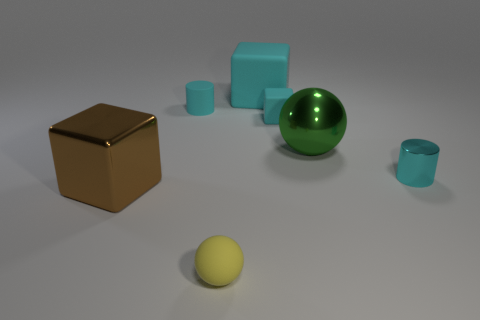What number of things are green objects that are left of the tiny metal thing or tiny objects that are in front of the small cyan cube?
Make the answer very short. 3. Is the number of large rubber blocks that are left of the big cyan rubber thing greater than the number of big blue blocks?
Your answer should be very brief. No. How many cyan rubber cubes have the same size as the green metallic ball?
Give a very brief answer. 1. Do the object in front of the brown cube and the sphere that is to the right of the tiny yellow sphere have the same size?
Provide a succinct answer. No. There is a ball in front of the large ball; how big is it?
Provide a short and direct response. Small. What size is the cyan cylinder to the left of the cyan cylinder on the right side of the large metal sphere?
Ensure brevity in your answer.  Small. There is a cyan cube that is the same size as the green sphere; what is it made of?
Ensure brevity in your answer.  Rubber. There is a metal ball; are there any large brown things on the right side of it?
Ensure brevity in your answer.  No. Are there an equal number of rubber objects right of the big green object and metal spheres?
Provide a short and direct response. No. What shape is the metallic object that is the same size as the yellow ball?
Your answer should be very brief. Cylinder. 